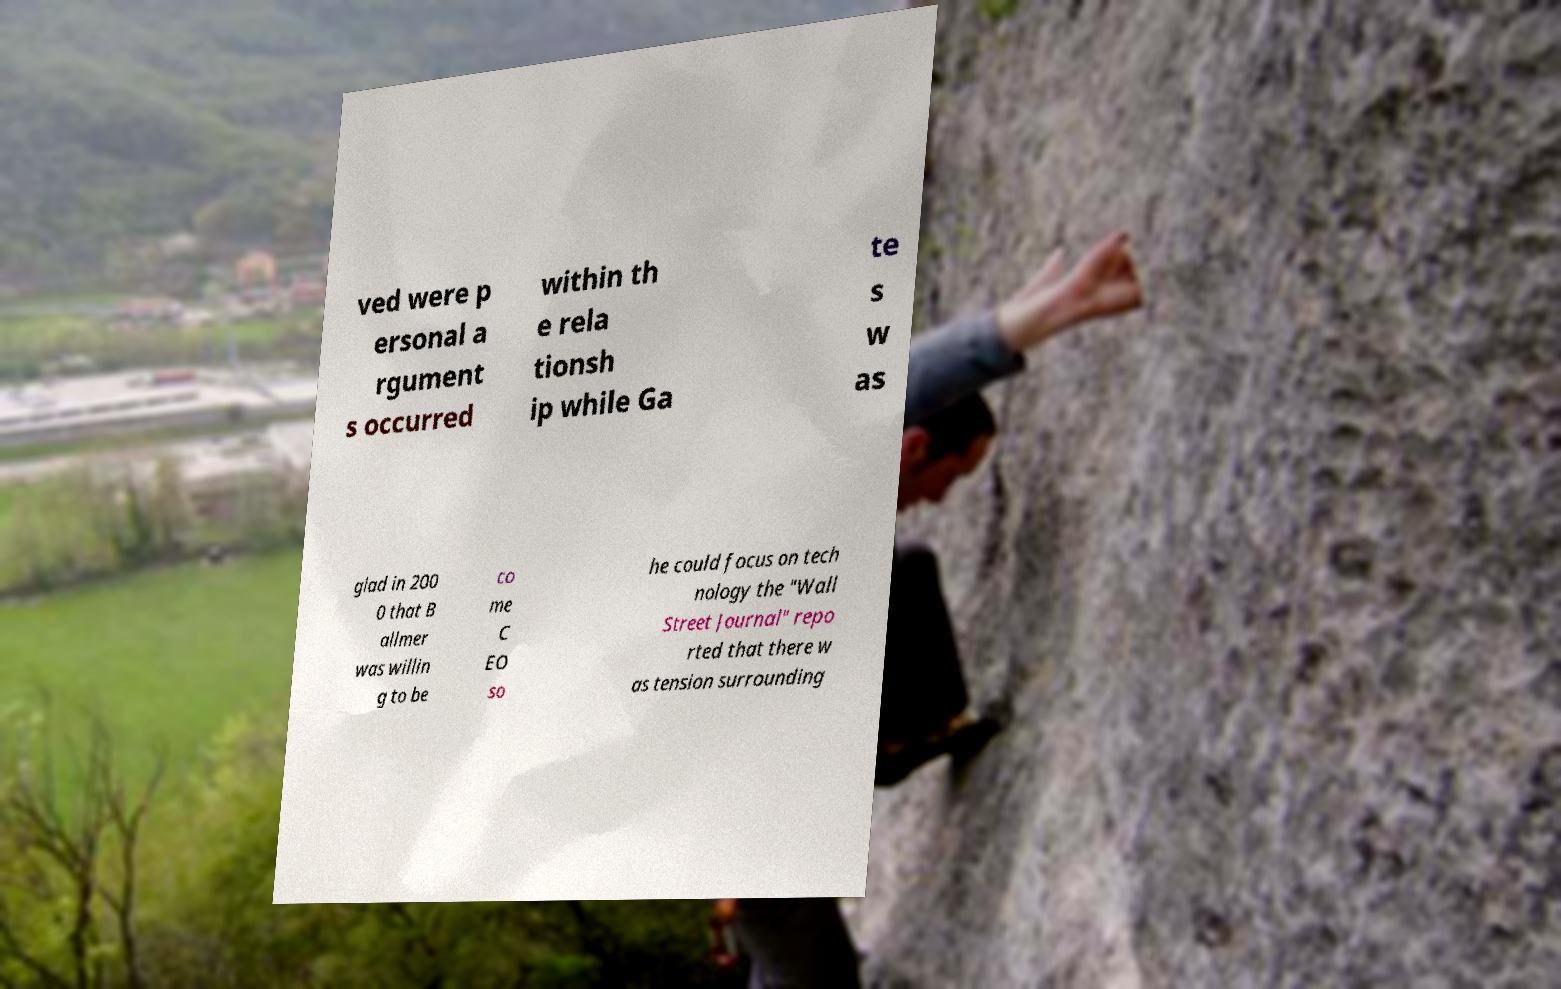Please identify and transcribe the text found in this image. ved were p ersonal a rgument s occurred within th e rela tionsh ip while Ga te s w as glad in 200 0 that B allmer was willin g to be co me C EO so he could focus on tech nology the "Wall Street Journal" repo rted that there w as tension surrounding 